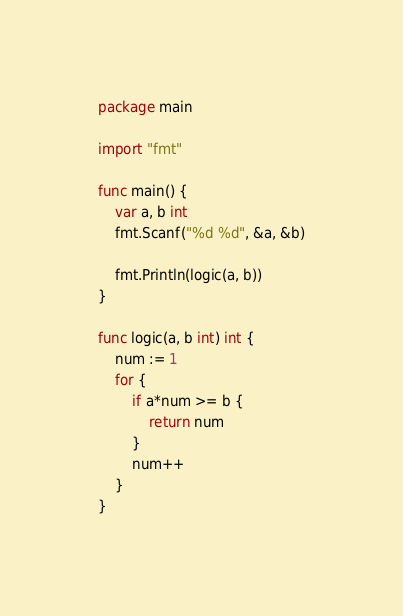<code> <loc_0><loc_0><loc_500><loc_500><_Go_>package main

import "fmt"

func main() {
	var a, b int
	fmt.Scanf("%d %d", &a, &b)

	fmt.Println(logic(a, b))
}

func logic(a, b int) int {
	num := 1
	for {
		if a*num >= b {
			return num
		}
		num++
	}
}</code> 